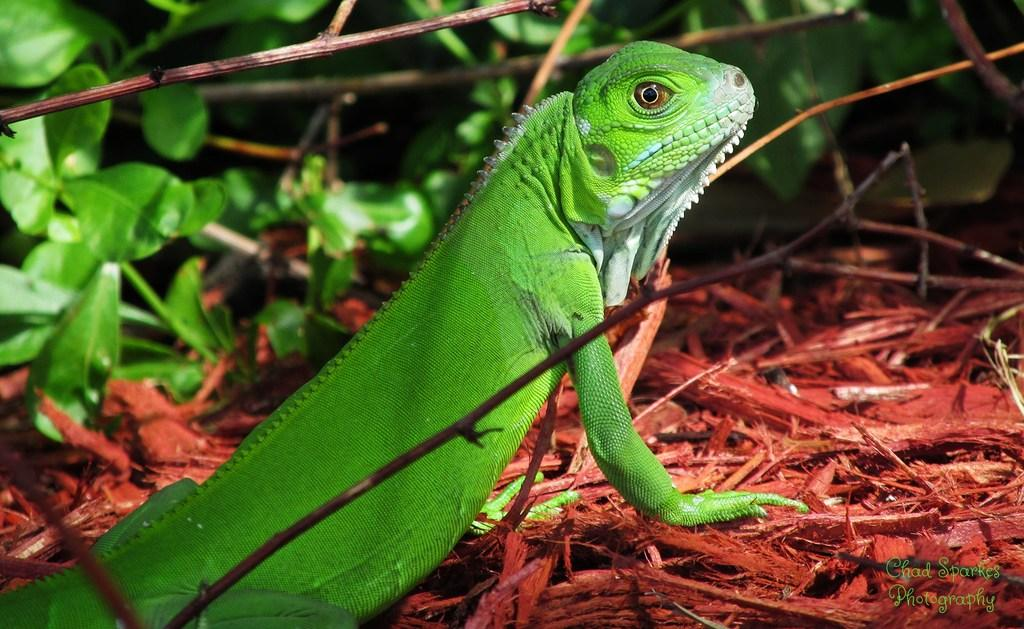What type of animal is in the image? There is a chameleon in the image. Where is the chameleon located? The chameleon is on the ground. What else can be seen in the image besides the chameleon? There are plants in the image. What type of silk is the chameleon using to blend in with the plants in the image? There is no silk present in the image, and the chameleon is not using any silk to blend in with the plants. 